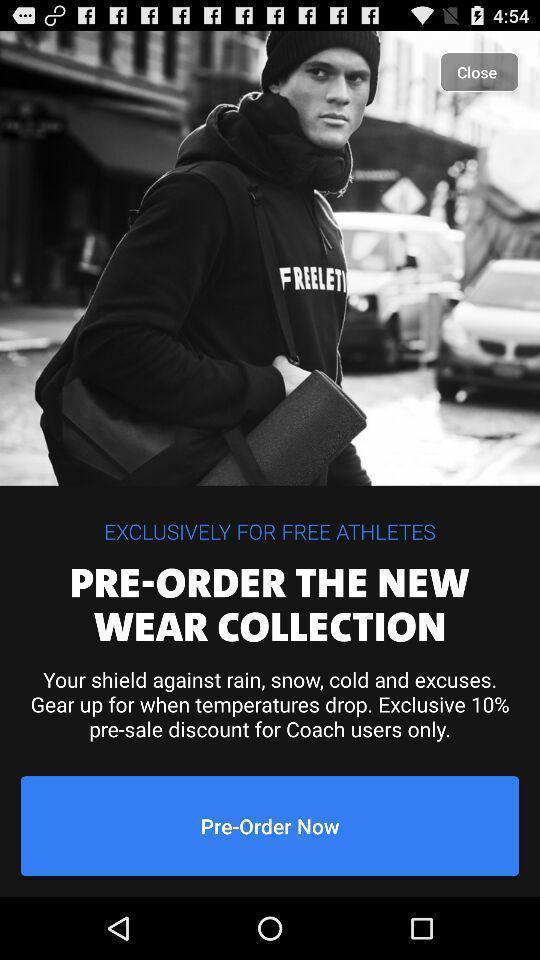Summarize the information in this screenshot. Screen displaying the notification regarding discount on shopping app. 